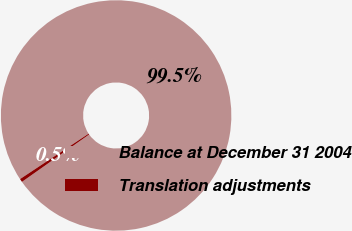<chart> <loc_0><loc_0><loc_500><loc_500><pie_chart><fcel>Balance at December 31 2004<fcel>Translation adjustments<nl><fcel>99.53%<fcel>0.47%<nl></chart> 